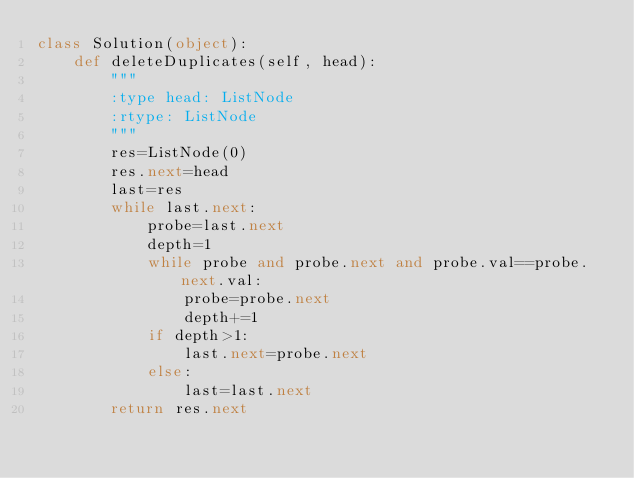<code> <loc_0><loc_0><loc_500><loc_500><_Python_>class Solution(object):
    def deleteDuplicates(self, head):
        """
        :type head: ListNode
        :rtype: ListNode
        """
        res=ListNode(0)
        res.next=head
        last=res
        while last.next:
            probe=last.next
            depth=1
            while probe and probe.next and probe.val==probe.next.val:
                probe=probe.next
                depth+=1
            if depth>1:
                last.next=probe.next
            else:
                last=last.next
        return res.next</code> 